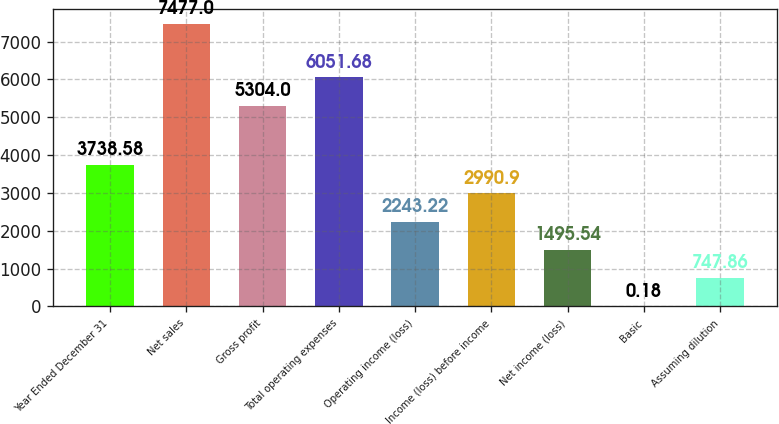Convert chart to OTSL. <chart><loc_0><loc_0><loc_500><loc_500><bar_chart><fcel>Year Ended December 31<fcel>Net sales<fcel>Gross profit<fcel>Total operating expenses<fcel>Operating income (loss)<fcel>Income (loss) before income<fcel>Net income (loss)<fcel>Basic<fcel>Assuming dilution<nl><fcel>3738.58<fcel>7477<fcel>5304<fcel>6051.68<fcel>2243.22<fcel>2990.9<fcel>1495.54<fcel>0.18<fcel>747.86<nl></chart> 